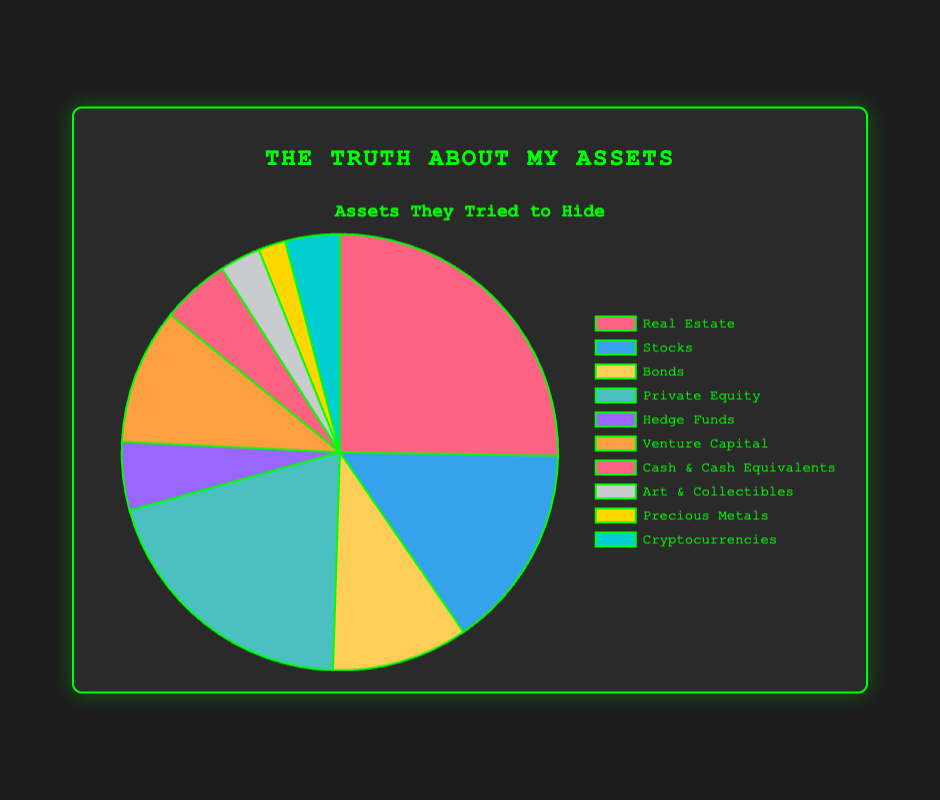Which asset type has the highest value? The asset type with the highest value can be identified by looking at the largest segment of the pie chart. Real Estate has a value of $25,000,000, which is the highest value among all asset types.
Answer: Real Estate Which asset type has the smallest value? The asset type with the smallest value can be identified by looking at the smallest segment of the pie chart. Precious Metals have a value of $2,000,000, which is the lowest value among all asset types.
Answer: Precious Metals How does the value of Stocks compare to Private Equity? Compare the segments for Stocks and Private Equity. Stocks have a value of $15,000,000, while Private Equity has a value of $20,000,000. Private Equity's value is higher.
Answer: Private Equity is higher What is the total value of Cash & Cash Equivalents and Cryptocurrencies? To find the total value, sum the values of Cash & Cash Equivalents and Cryptocurrencies: $5,000,000 + $4,000,000. This equals $9,000,000.
Answer: $9,000,000 What's the difference in value between Hedge Funds and Venture Capital? Subtract the value of Hedge Funds from Venture Capital: $10,000,000 - $5,000,000. This equals $5,000,000.
Answer: $5,000,000 What is the combined value of Bonds and Art & Collectibles? Sum the values of Bonds and Art & Collectibles: $10,000,000 + $3,000,000. This equals $13,000,000.
Answer: $13,000,000 What percentage of the total assets does Real Estate represent? To find the percentage, divide the value of Real Estate by the total value of all assets and multiply by 100. Total assets value is $90,000,000. The calculation is (25,000,000 / 90,000,000) * 100. This equals about 27.78%.
Answer: 27.78% Which asset type represented by a blue segment? The pie chart's blue segment represents Stocks, with a value of $15,000,000.
Answer: Stocks What is the sum of the values of all types of assets with values under $10,000,000? Sum the values of Hedge Funds ($5,000,000), Cash & Cash Equivalents ($5,000,000), Art & Collectibles ($3,000,000), Precious Metals ($2,000,000), and Cryptocurrencies ($4,000,000). The calculation is $5,000,000 + $5,000,000 + $3,000,000 + $2,000,000 + $4,000,000 = $19,000,000.
Answer: $19,000,000 